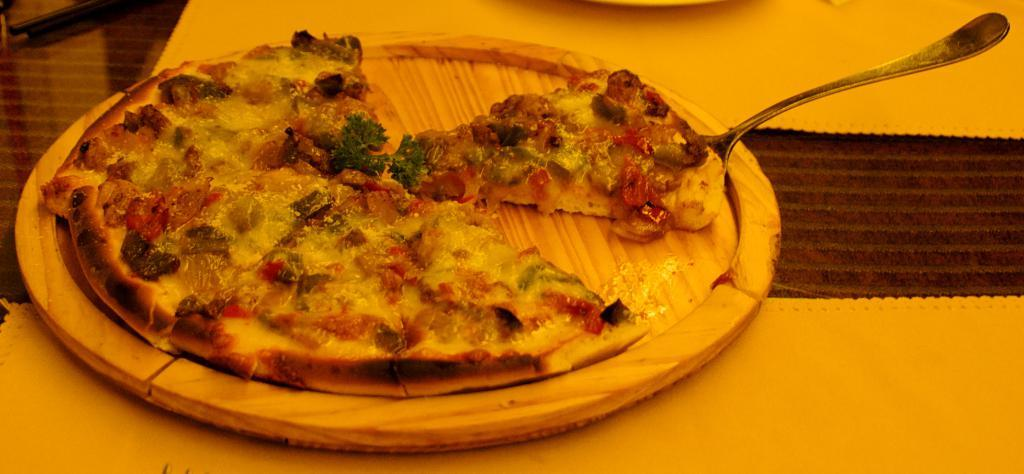What type of plate is in the image? There is a wooden plate in the image. What is on the wooden plate? There is a pizza on the wooden plate. Can you describe anything on the right side of the image? There is a piece of pizza on a spoon on the right side of the image. What type of question is being asked by the pizza in the image? There is no indication in the image that the pizza is asking any questions. 